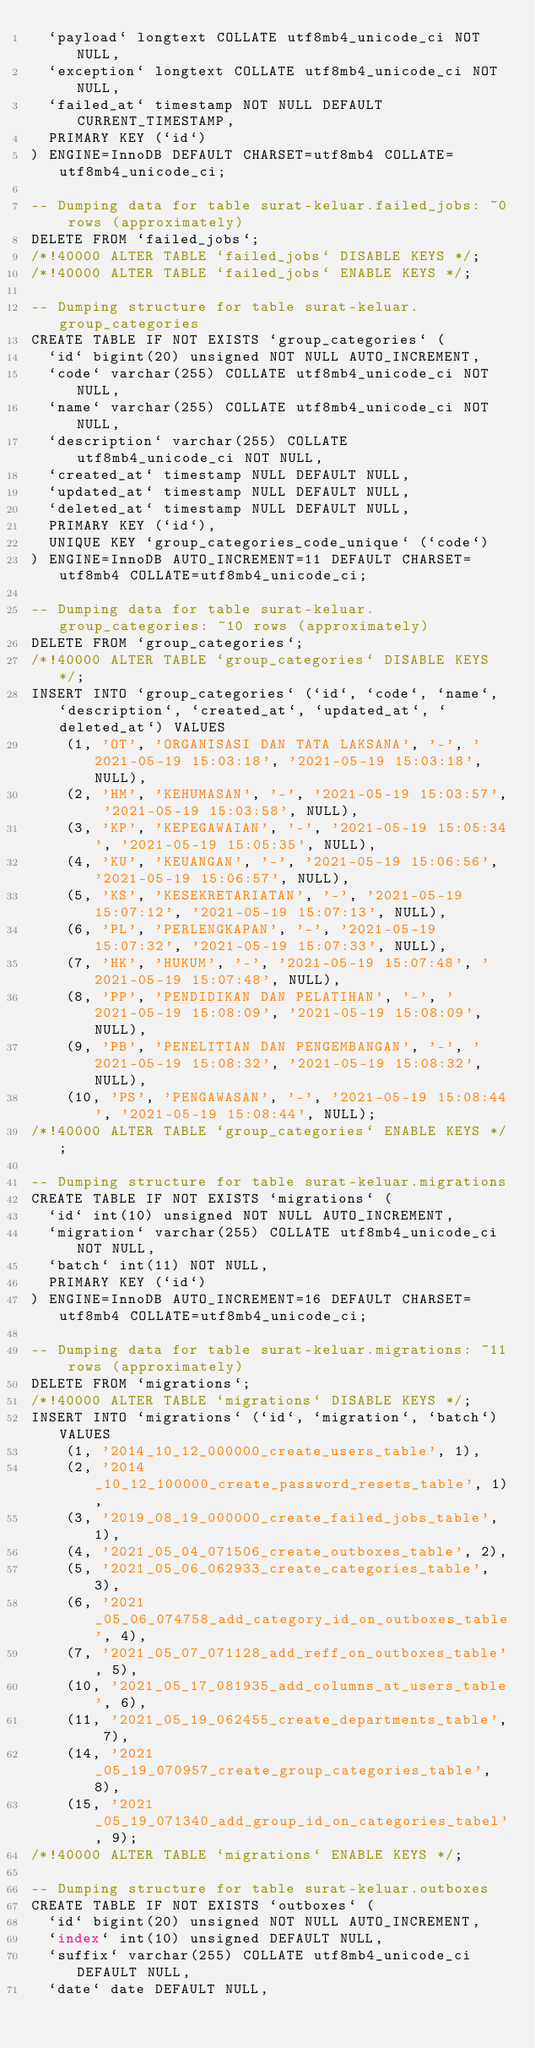Convert code to text. <code><loc_0><loc_0><loc_500><loc_500><_SQL_>  `payload` longtext COLLATE utf8mb4_unicode_ci NOT NULL,
  `exception` longtext COLLATE utf8mb4_unicode_ci NOT NULL,
  `failed_at` timestamp NOT NULL DEFAULT CURRENT_TIMESTAMP,
  PRIMARY KEY (`id`)
) ENGINE=InnoDB DEFAULT CHARSET=utf8mb4 COLLATE=utf8mb4_unicode_ci;

-- Dumping data for table surat-keluar.failed_jobs: ~0 rows (approximately)
DELETE FROM `failed_jobs`;
/*!40000 ALTER TABLE `failed_jobs` DISABLE KEYS */;
/*!40000 ALTER TABLE `failed_jobs` ENABLE KEYS */;

-- Dumping structure for table surat-keluar.group_categories
CREATE TABLE IF NOT EXISTS `group_categories` (
  `id` bigint(20) unsigned NOT NULL AUTO_INCREMENT,
  `code` varchar(255) COLLATE utf8mb4_unicode_ci NOT NULL,
  `name` varchar(255) COLLATE utf8mb4_unicode_ci NOT NULL,
  `description` varchar(255) COLLATE utf8mb4_unicode_ci NOT NULL,
  `created_at` timestamp NULL DEFAULT NULL,
  `updated_at` timestamp NULL DEFAULT NULL,
  `deleted_at` timestamp NULL DEFAULT NULL,
  PRIMARY KEY (`id`),
  UNIQUE KEY `group_categories_code_unique` (`code`)
) ENGINE=InnoDB AUTO_INCREMENT=11 DEFAULT CHARSET=utf8mb4 COLLATE=utf8mb4_unicode_ci;

-- Dumping data for table surat-keluar.group_categories: ~10 rows (approximately)
DELETE FROM `group_categories`;
/*!40000 ALTER TABLE `group_categories` DISABLE KEYS */;
INSERT INTO `group_categories` (`id`, `code`, `name`, `description`, `created_at`, `updated_at`, `deleted_at`) VALUES
	(1, 'OT', 'ORGANISASI DAN TATA LAKSANA', '-', '2021-05-19 15:03:18', '2021-05-19 15:03:18', NULL),
	(2, 'HM', 'KEHUMASAN', '-', '2021-05-19 15:03:57', '2021-05-19 15:03:58', NULL),
	(3, 'KP', 'KEPEGAWAIAN', '-', '2021-05-19 15:05:34', '2021-05-19 15:05:35', NULL),
	(4, 'KU', 'KEUANGAN', '-', '2021-05-19 15:06:56', '2021-05-19 15:06:57', NULL),
	(5, 'KS', 'KESEKRETARIATAN', '-', '2021-05-19 15:07:12', '2021-05-19 15:07:13', NULL),
	(6, 'PL', 'PERLENGKAPAN', '-', '2021-05-19 15:07:32', '2021-05-19 15:07:33', NULL),
	(7, 'HK', 'HUKUM', '-', '2021-05-19 15:07:48', '2021-05-19 15:07:48', NULL),
	(8, 'PP', 'PENDIDIKAN DAN PELATIHAN', '-', '2021-05-19 15:08:09', '2021-05-19 15:08:09', NULL),
	(9, 'PB', 'PENELITIAN DAN PENGEMBANGAN', '-', '2021-05-19 15:08:32', '2021-05-19 15:08:32', NULL),
	(10, 'PS', 'PENGAWASAN', '-', '2021-05-19 15:08:44', '2021-05-19 15:08:44', NULL);
/*!40000 ALTER TABLE `group_categories` ENABLE KEYS */;

-- Dumping structure for table surat-keluar.migrations
CREATE TABLE IF NOT EXISTS `migrations` (
  `id` int(10) unsigned NOT NULL AUTO_INCREMENT,
  `migration` varchar(255) COLLATE utf8mb4_unicode_ci NOT NULL,
  `batch` int(11) NOT NULL,
  PRIMARY KEY (`id`)
) ENGINE=InnoDB AUTO_INCREMENT=16 DEFAULT CHARSET=utf8mb4 COLLATE=utf8mb4_unicode_ci;

-- Dumping data for table surat-keluar.migrations: ~11 rows (approximately)
DELETE FROM `migrations`;
/*!40000 ALTER TABLE `migrations` DISABLE KEYS */;
INSERT INTO `migrations` (`id`, `migration`, `batch`) VALUES
	(1, '2014_10_12_000000_create_users_table', 1),
	(2, '2014_10_12_100000_create_password_resets_table', 1),
	(3, '2019_08_19_000000_create_failed_jobs_table', 1),
	(4, '2021_05_04_071506_create_outboxes_table', 2),
	(5, '2021_05_06_062933_create_categories_table', 3),
	(6, '2021_05_06_074758_add_category_id_on_outboxes_table', 4),
	(7, '2021_05_07_071128_add_reff_on_outboxes_table', 5),
	(10, '2021_05_17_081935_add_columns_at_users_table', 6),
	(11, '2021_05_19_062455_create_departments_table', 7),
	(14, '2021_05_19_070957_create_group_categories_table', 8),
	(15, '2021_05_19_071340_add_group_id_on_categories_tabel', 9);
/*!40000 ALTER TABLE `migrations` ENABLE KEYS */;

-- Dumping structure for table surat-keluar.outboxes
CREATE TABLE IF NOT EXISTS `outboxes` (
  `id` bigint(20) unsigned NOT NULL AUTO_INCREMENT,
  `index` int(10) unsigned DEFAULT NULL,
  `suffix` varchar(255) COLLATE utf8mb4_unicode_ci DEFAULT NULL,
  `date` date DEFAULT NULL,</code> 